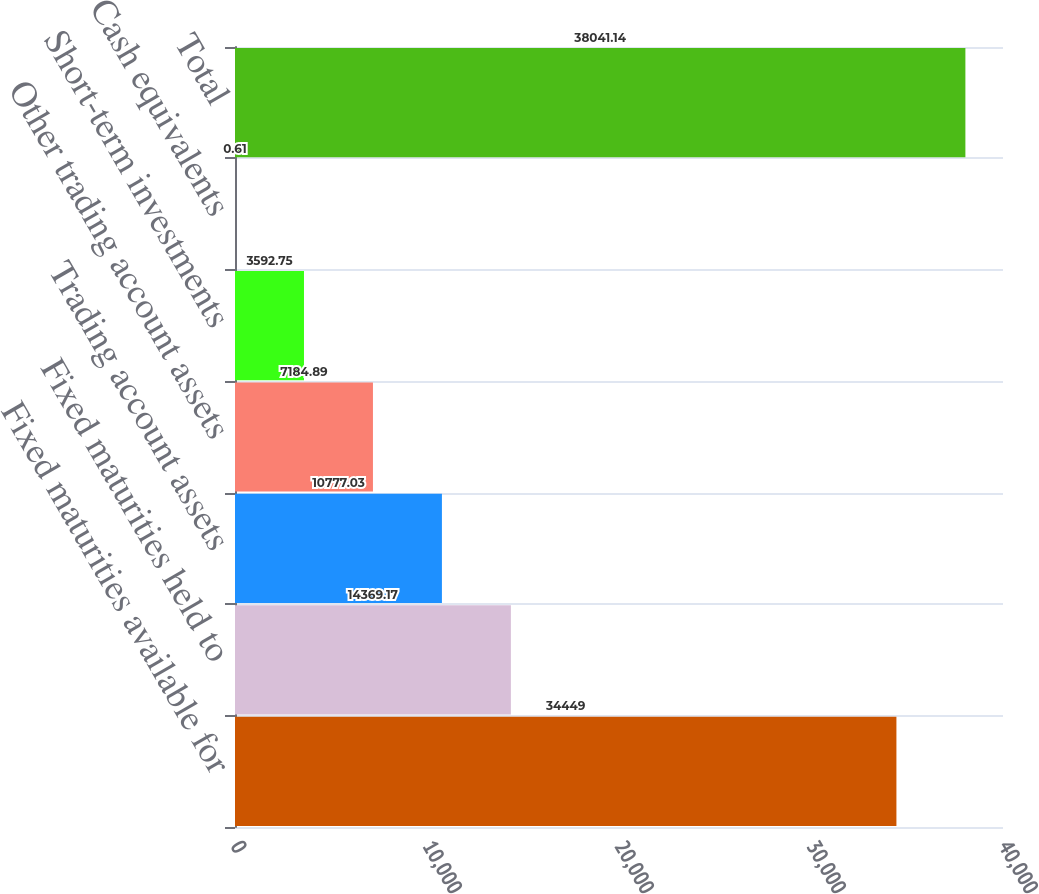Convert chart to OTSL. <chart><loc_0><loc_0><loc_500><loc_500><bar_chart><fcel>Fixed maturities available for<fcel>Fixed maturities held to<fcel>Trading account assets<fcel>Other trading account assets<fcel>Short-term investments<fcel>Cash equivalents<fcel>Total<nl><fcel>34449<fcel>14369.2<fcel>10777<fcel>7184.89<fcel>3592.75<fcel>0.61<fcel>38041.1<nl></chart> 